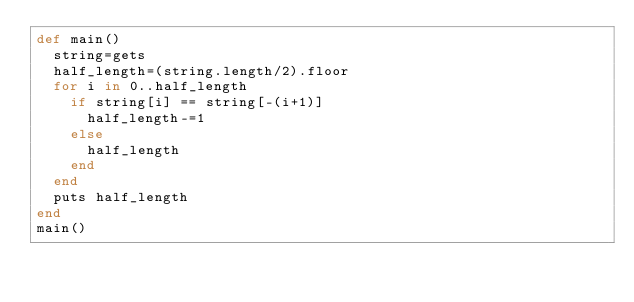Convert code to text. <code><loc_0><loc_0><loc_500><loc_500><_Ruby_>def main()
  string=gets
  half_length=(string.length/2).floor
  for i in 0..half_length
    if string[i] == string[-(i+1)]
      half_length-=1
    else
      half_length
    end
  end
  puts half_length
end
main()</code> 